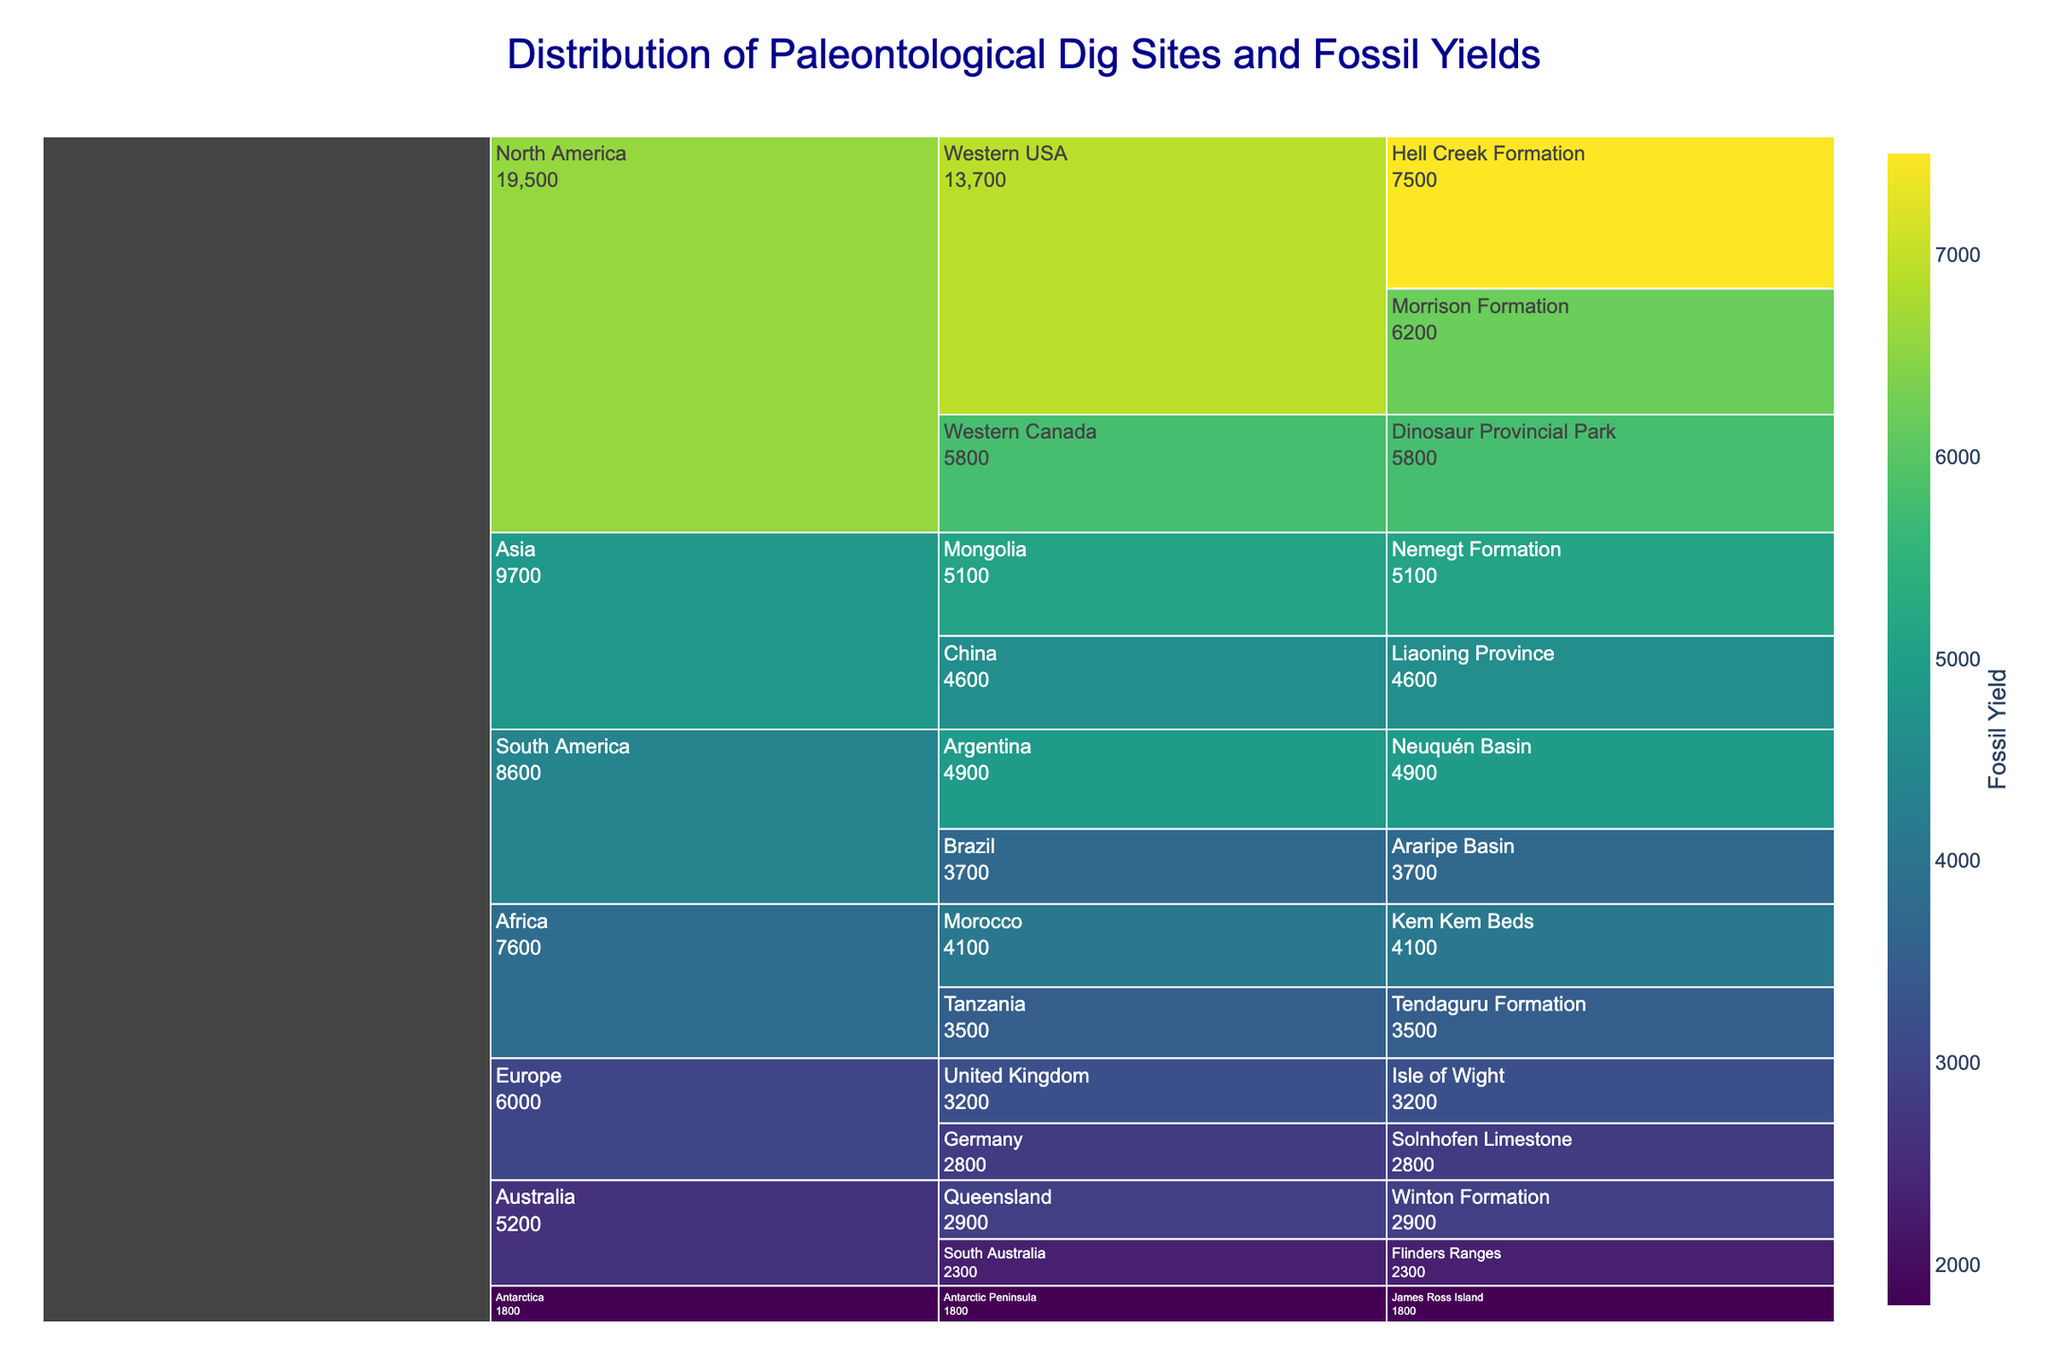What is the fossil yield for James Ross Island in Antarctica? Locate the continent (Antarctica) in the chart, then find the region (Antarctic Peninsula), and finally the site (James Ross Island). The fossil yield displayed for James Ross Island is 1800.
Answer: 1800 Which continent has the highest total fossil yield? Each continent displays the accumulated fossil yields from all its regions and sites. North America has the highest combined fossil yield, as seen from the larger size of its section in the chart.
Answer: North America How does the fossil yield of the Hell Creek Formation compare to the Morrison Formation? Locate both sites under the continent of North America and the region of Western USA. The Hell Creek Formation has a fossil yield of 7500, while the Morrison Formation has 6200. Hell Creek Formation has a higher yield by 1300.
Answer: Hell Creek Formation has a higher yield by 1300 Which fossil site in Asia has the highest yield? Find the continent Asia, then compare the fossil yields of the sites (Nemegt Formation in Mongolia and Liaoning Province in China). The Nemegt Formation has the highest yield with 5100.
Answer: Nemegt Formation How many fossil sites are there in Europe, and what are their fossil yields? Locate the continent Europe and count the sites listed: Isle of Wight and Solnhofen Limestone. Their fossil yields are 3200 and 2800, respectively.
Answer: 2 sites; 3200 and 2800 What is the total fossil yield for the continent of Africa? Find Africa in the chart and add the fossil yields for Kem Kem Beds (4100) and Tendaguru Formation (3500). The total yield is 4100 + 3500 = 7600.
Answer: 7600 Which region in Australia has the lowest fossil yield? Locate the continent Australia and compare the yields of the two regions, Winton Formation (2900) and Flinders Ranges (2300). Flinders Ranges has the lower fossil yield.
Answer: Flinders Ranges Is the fossil yield of the Argentine Neuquén Basin higher or lower than the Chinese Liaoning Province? Compare the fossil yields listed under South America (Neuquén Basin: 4900) and Asia (Liaoning Province: 4600). Neuquén Basin has a higher yield.
Answer: Neuquén Basin is higher Calculate the average fossil yield for sites in the South America region. Identify the South America sites (Neuquén Basin with 4900 and Araripe Basin with 3700), sum them (4900 + 3700 = 8600), and divide by the number of sites (2). The average yield is 8600 / 2 = 4300.
Answer: 4300 